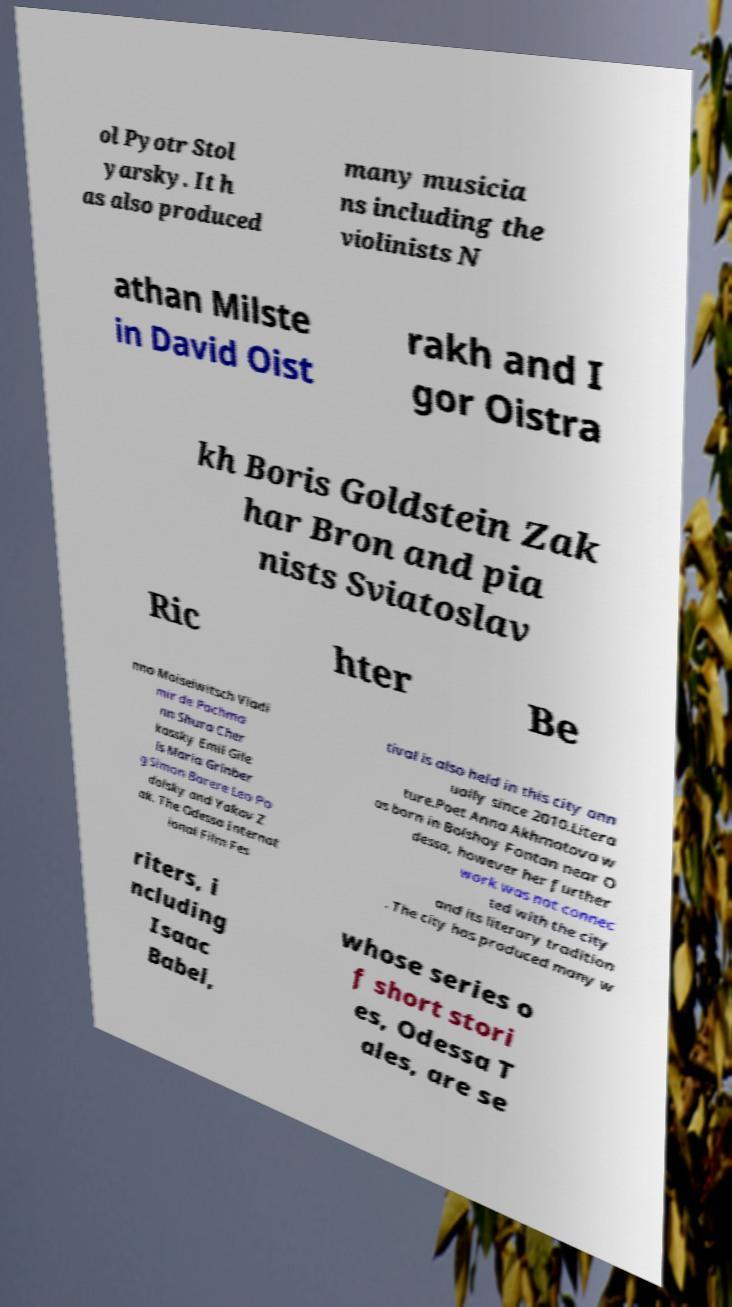Can you accurately transcribe the text from the provided image for me? ol Pyotr Stol yarsky. It h as also produced many musicia ns including the violinists N athan Milste in David Oist rakh and I gor Oistra kh Boris Goldstein Zak har Bron and pia nists Sviatoslav Ric hter Be nno Moiseiwitsch Vladi mir de Pachma nn Shura Cher kassky Emil Gile ls Maria Grinber g Simon Barere Leo Po dolsky and Yakov Z ak. The Odessa Internat ional Film Fes tival is also held in this city ann ually since 2010.Litera ture.Poet Anna Akhmatova w as born in Bolshoy Fontan near O dessa, however her further work was not connec ted with the city and its literary tradition . The city has produced many w riters, i ncluding Isaac Babel, whose series o f short stori es, Odessa T ales, are se 